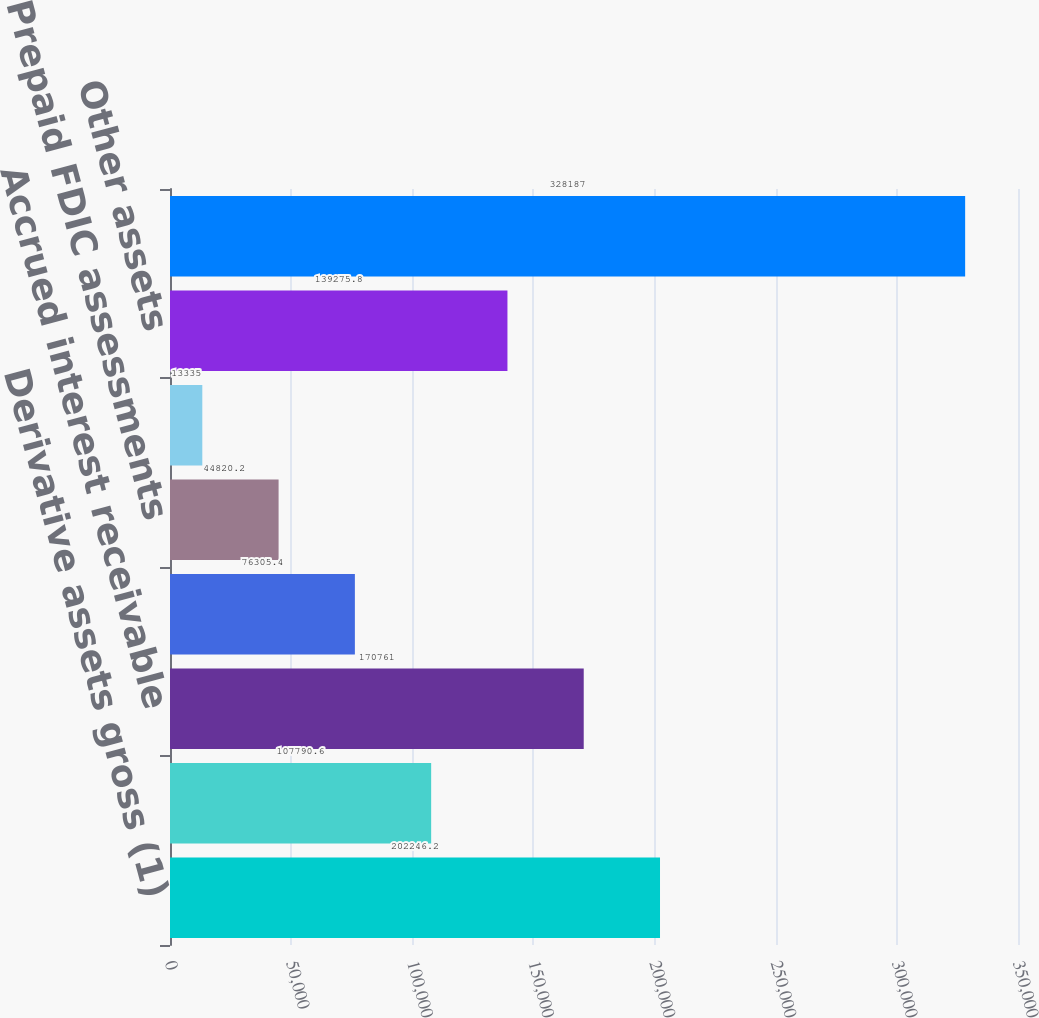Convert chart to OTSL. <chart><loc_0><loc_0><loc_500><loc_500><bar_chart><fcel>Derivative assets gross (1)<fcel>Deferred tax assets<fcel>Accrued interest receivable<fcel>FHLB and FRB stock<fcel>Prepaid FDIC assessments<fcel>Foreign exchange spot contract<fcel>Other assets<fcel>Total accrued interest<nl><fcel>202246<fcel>107791<fcel>170761<fcel>76305.4<fcel>44820.2<fcel>13335<fcel>139276<fcel>328187<nl></chart> 